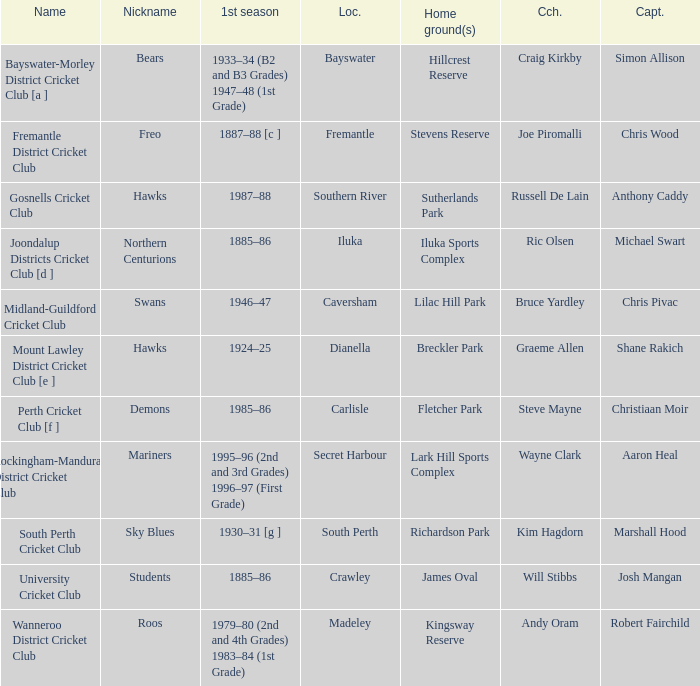For location Caversham, what is the name of the captain? Chris Pivac. 